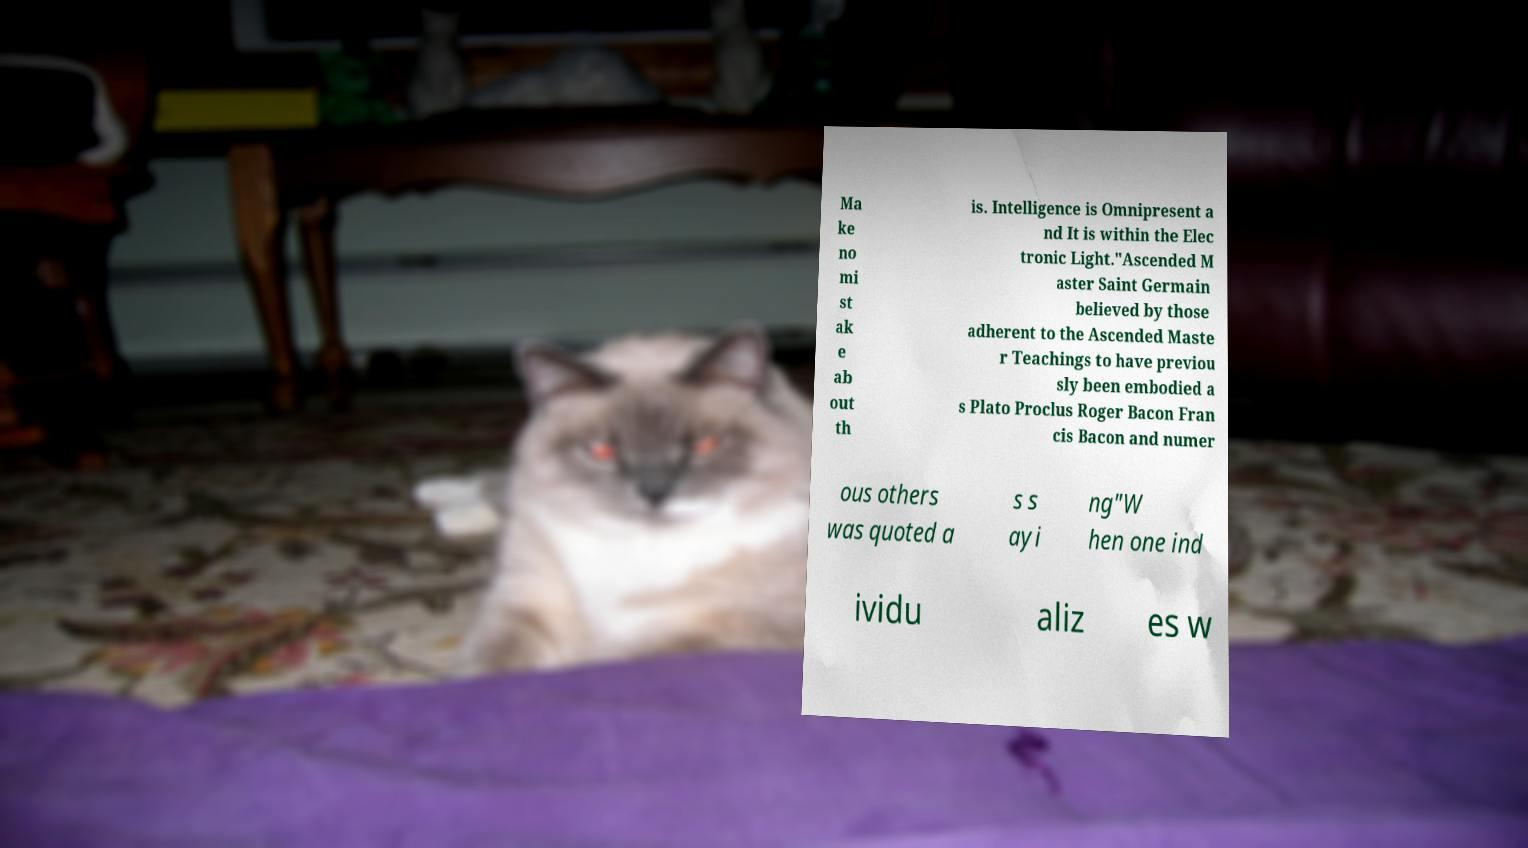Can you accurately transcribe the text from the provided image for me? Ma ke no mi st ak e ab out th is. Intelligence is Omnipresent a nd It is within the Elec tronic Light."Ascended M aster Saint Germain believed by those adherent to the Ascended Maste r Teachings to have previou sly been embodied a s Plato Proclus Roger Bacon Fran cis Bacon and numer ous others was quoted a s s ayi ng"W hen one ind ividu aliz es w 